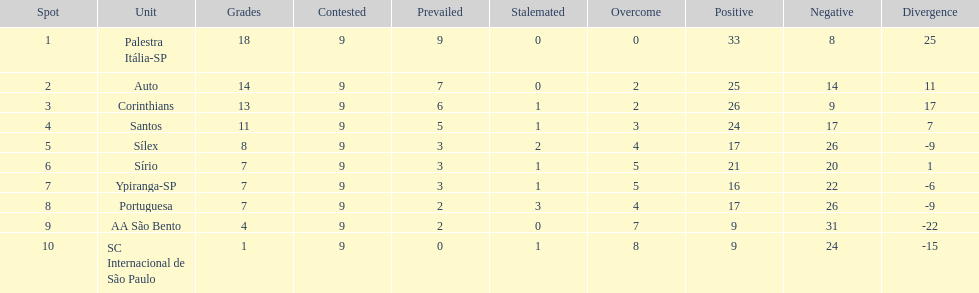In 1926 brazilian football,what was the total number of points scored? 90. 